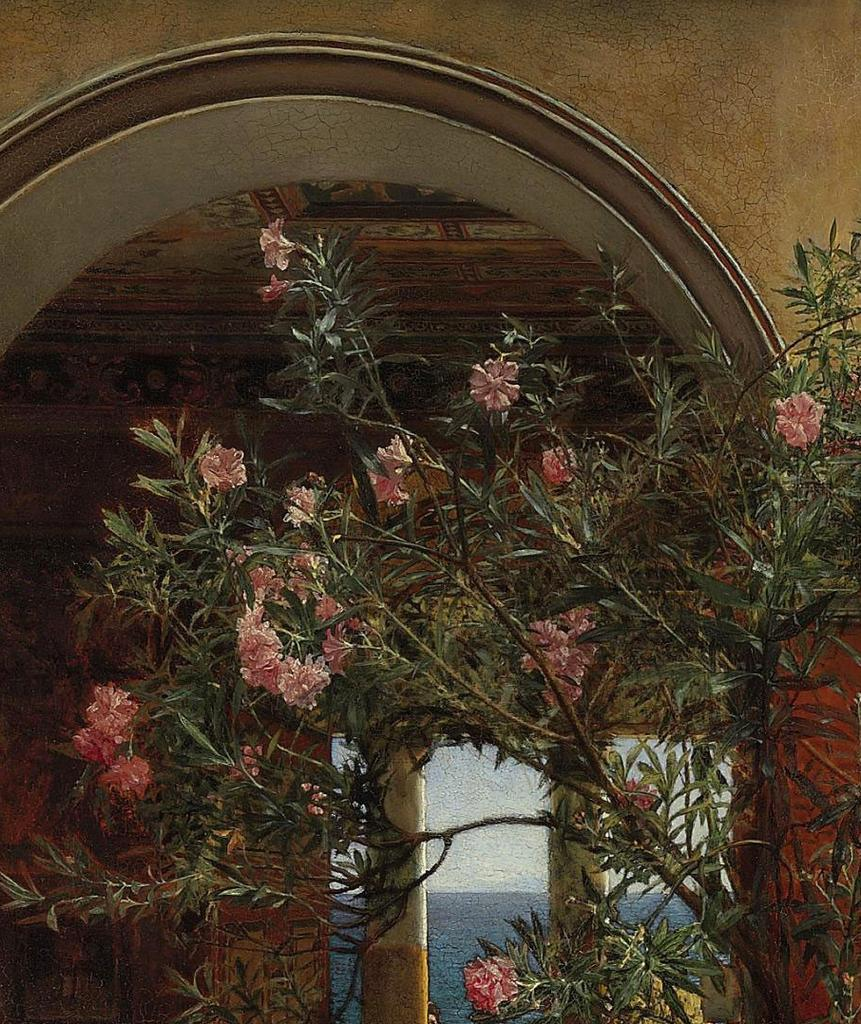What type of plant is visible in the image? There is a plant with flowers in the image. What can be seen in the background of the image? There is a wall, a roof, pillars, water, and the sky visible in the background of the image. How does the plant compare to the airport in the image? There is no airport present in the image, so it cannot be compared to the plant. 